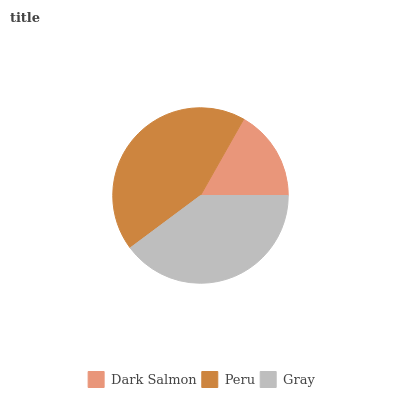Is Dark Salmon the minimum?
Answer yes or no. Yes. Is Peru the maximum?
Answer yes or no. Yes. Is Gray the minimum?
Answer yes or no. No. Is Gray the maximum?
Answer yes or no. No. Is Peru greater than Gray?
Answer yes or no. Yes. Is Gray less than Peru?
Answer yes or no. Yes. Is Gray greater than Peru?
Answer yes or no. No. Is Peru less than Gray?
Answer yes or no. No. Is Gray the high median?
Answer yes or no. Yes. Is Gray the low median?
Answer yes or no. Yes. Is Peru the high median?
Answer yes or no. No. Is Dark Salmon the low median?
Answer yes or no. No. 